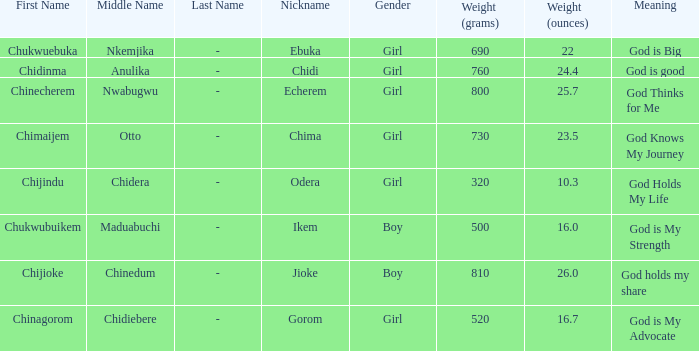How much did the baby who name means God knows my journey weigh at birth? 730g (23.5 oz.). 